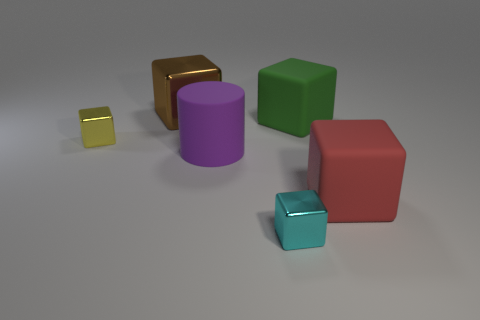Can you describe the lighting and shadows in the scene? The image features a soft overhead lighting that casts gentle shadows to the right of the objects, suggesting a diffused light source above and to the left of the scene. 